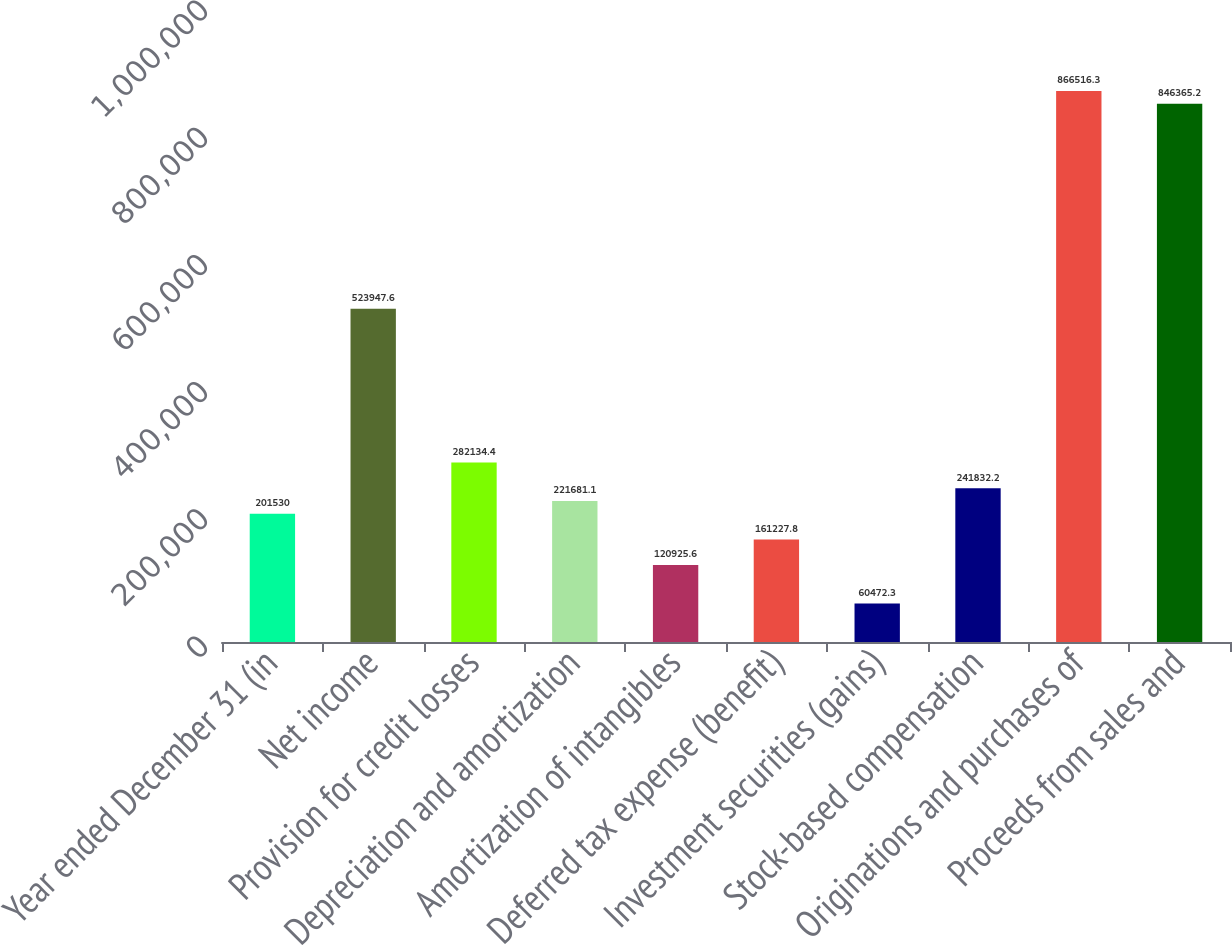Convert chart. <chart><loc_0><loc_0><loc_500><loc_500><bar_chart><fcel>Year ended December 31 (in<fcel>Net income<fcel>Provision for credit losses<fcel>Depreciation and amortization<fcel>Amortization of intangibles<fcel>Deferred tax expense (benefit)<fcel>Investment securities (gains)<fcel>Stock-based compensation<fcel>Originations and purchases of<fcel>Proceeds from sales and<nl><fcel>201530<fcel>523948<fcel>282134<fcel>221681<fcel>120926<fcel>161228<fcel>60472.3<fcel>241832<fcel>866516<fcel>846365<nl></chart> 